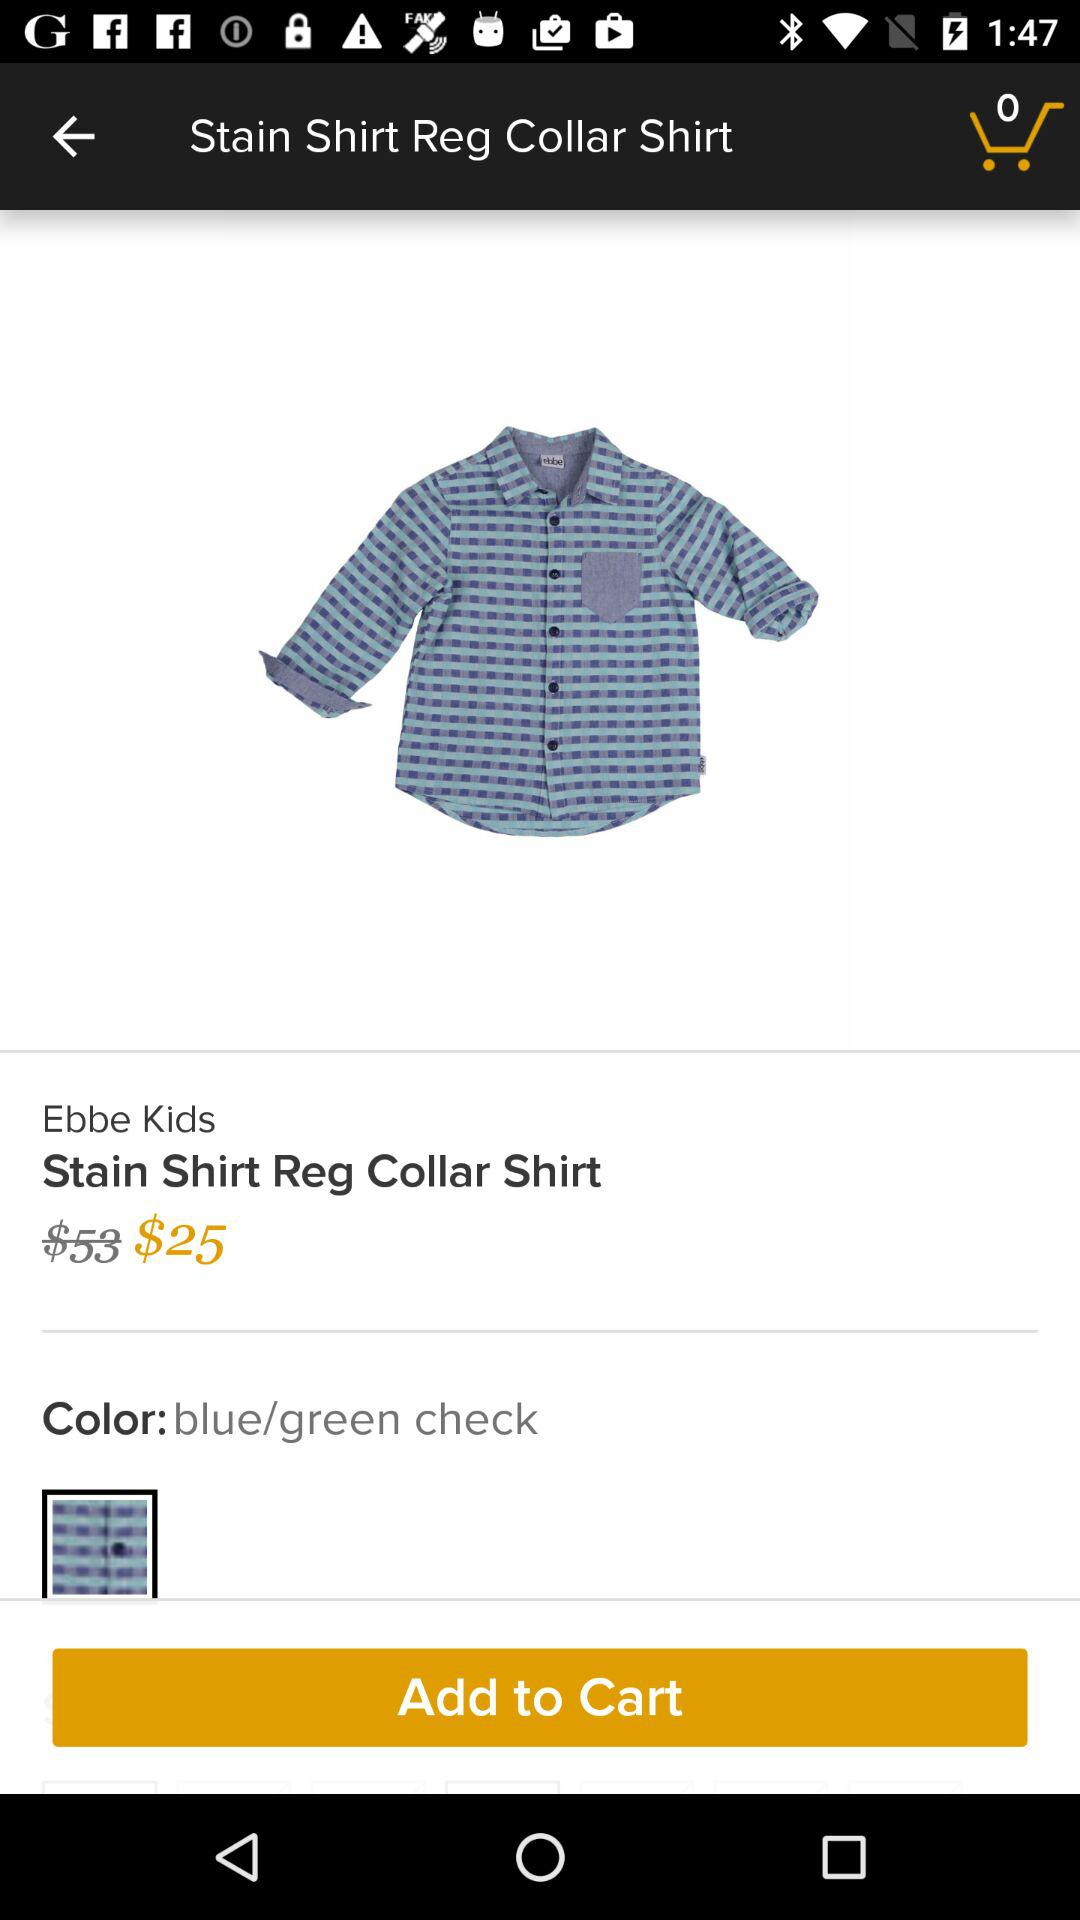What is the price of the shirt before the discount? The price of the shirt before the discount is $53. 